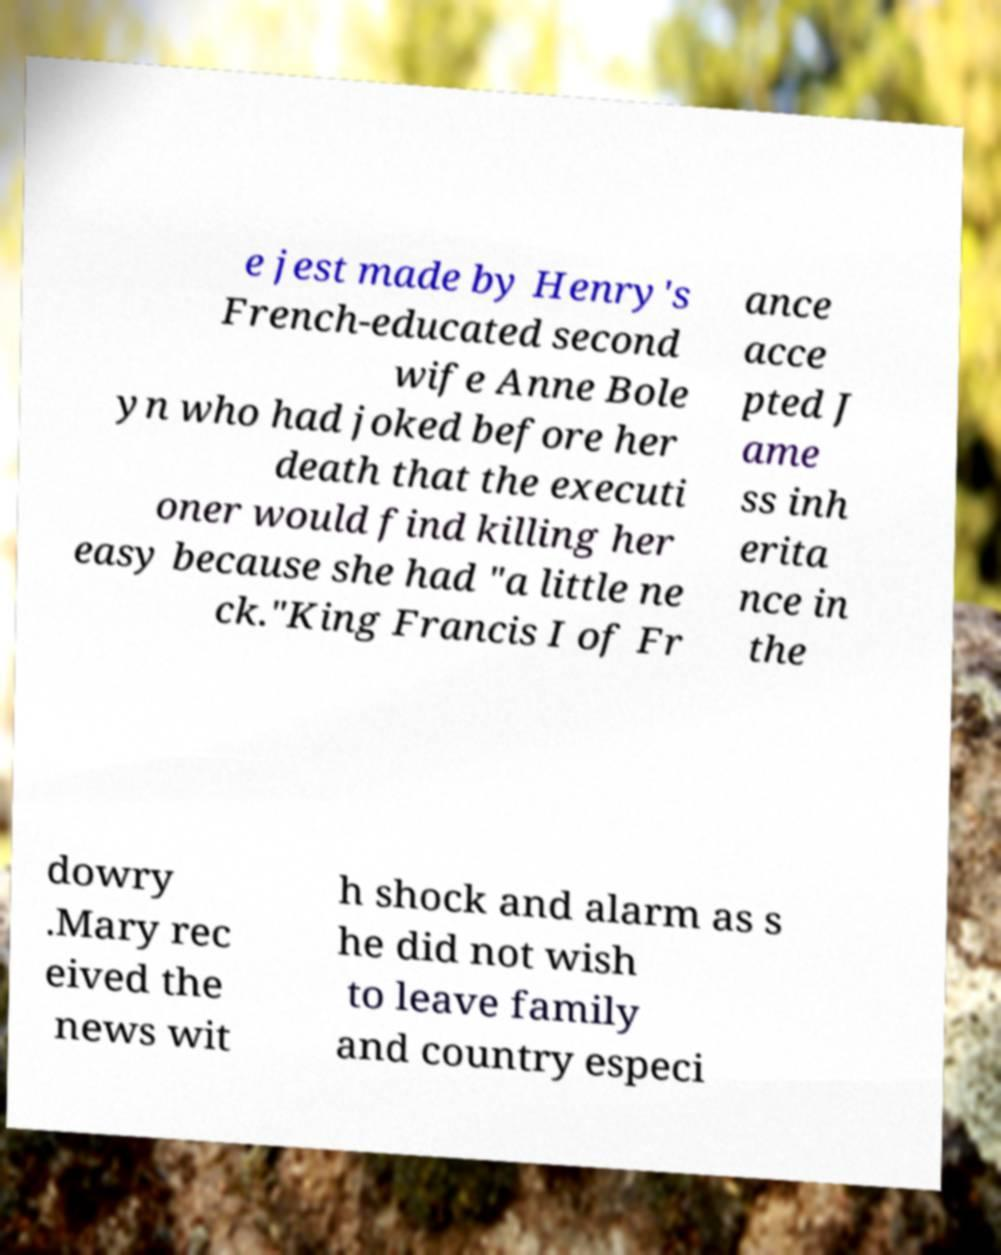What messages or text are displayed in this image? I need them in a readable, typed format. e jest made by Henry's French-educated second wife Anne Bole yn who had joked before her death that the executi oner would find killing her easy because she had "a little ne ck."King Francis I of Fr ance acce pted J ame ss inh erita nce in the dowry .Mary rec eived the news wit h shock and alarm as s he did not wish to leave family and country especi 